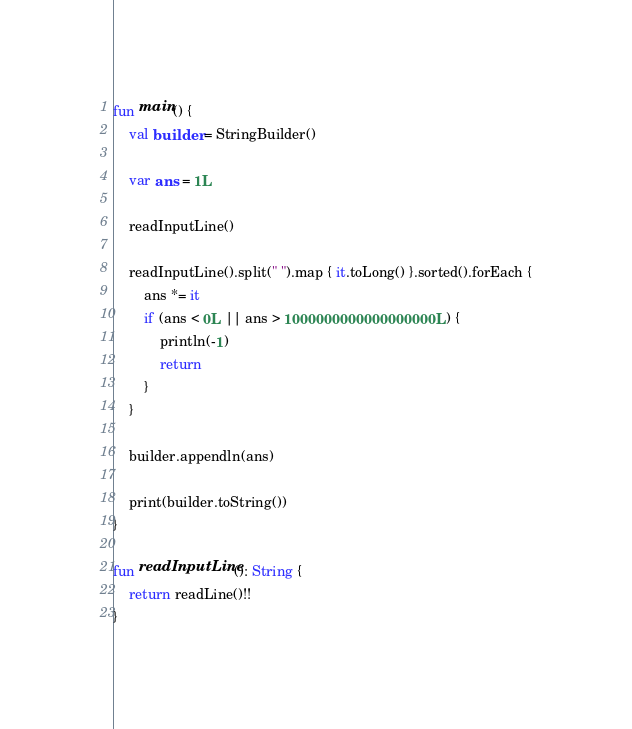<code> <loc_0><loc_0><loc_500><loc_500><_Kotlin_>fun main() {
    val builder = StringBuilder()

    var ans = 1L

    readInputLine()

    readInputLine().split(" ").map { it.toLong() }.sorted().forEach {
        ans *= it
        if (ans < 0L || ans > 1000000000000000000L) {
            println(-1)
            return
        }
    }

    builder.appendln(ans)

    print(builder.toString())
}

fun readInputLine(): String {
    return readLine()!!
}
</code> 